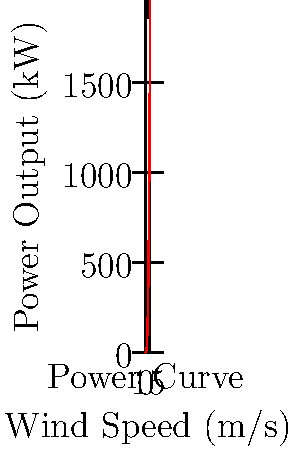A wind turbine has blades with a length of 25 meters and is operating in an area where the wind speed is 15 m/s. Using the power curve shown in the graph, estimate the power output of this turbine. How might this output impact local energy production during a labor strike at a nearby coal power plant? To solve this problem, we need to follow these steps:

1) First, we need to understand what the graph represents. The x-axis shows wind speed in m/s, and the y-axis shows power output in kW.

2) We're given that the wind speed is 15 m/s. We need to find the corresponding power output on the y-axis.

3) Looking at the graph, we can see that for a wind speed of 15 m/s, the power output is approximately 421.875 kW.

4) The blade length doesn't directly factor into this calculation, as the power curve already takes into account the turbine's specifications. However, it's worth noting that longer blades generally allow for greater power output.

5) To contextualize this in terms of the impact during a labor strike:
   - 421.875 kW is equivalent to 0.421875 MW
   - A typical coal power plant might produce anywhere from 600 to 2000 MW
   - So this single wind turbine could offset a small fraction of the lost power from a striking coal plant
   - Multiple wind turbines could provide significant supplementary power during the strike
   - This could help maintain some level of power supply, potentially reducing the economic impact of the strike

6) The reliability of wind power during the strike would depend on consistent wind conditions, which adds an element of variability to this alternative power source.
Answer: 421.875 kW; could partially offset lost coal power during strike, mitigating economic impact. 